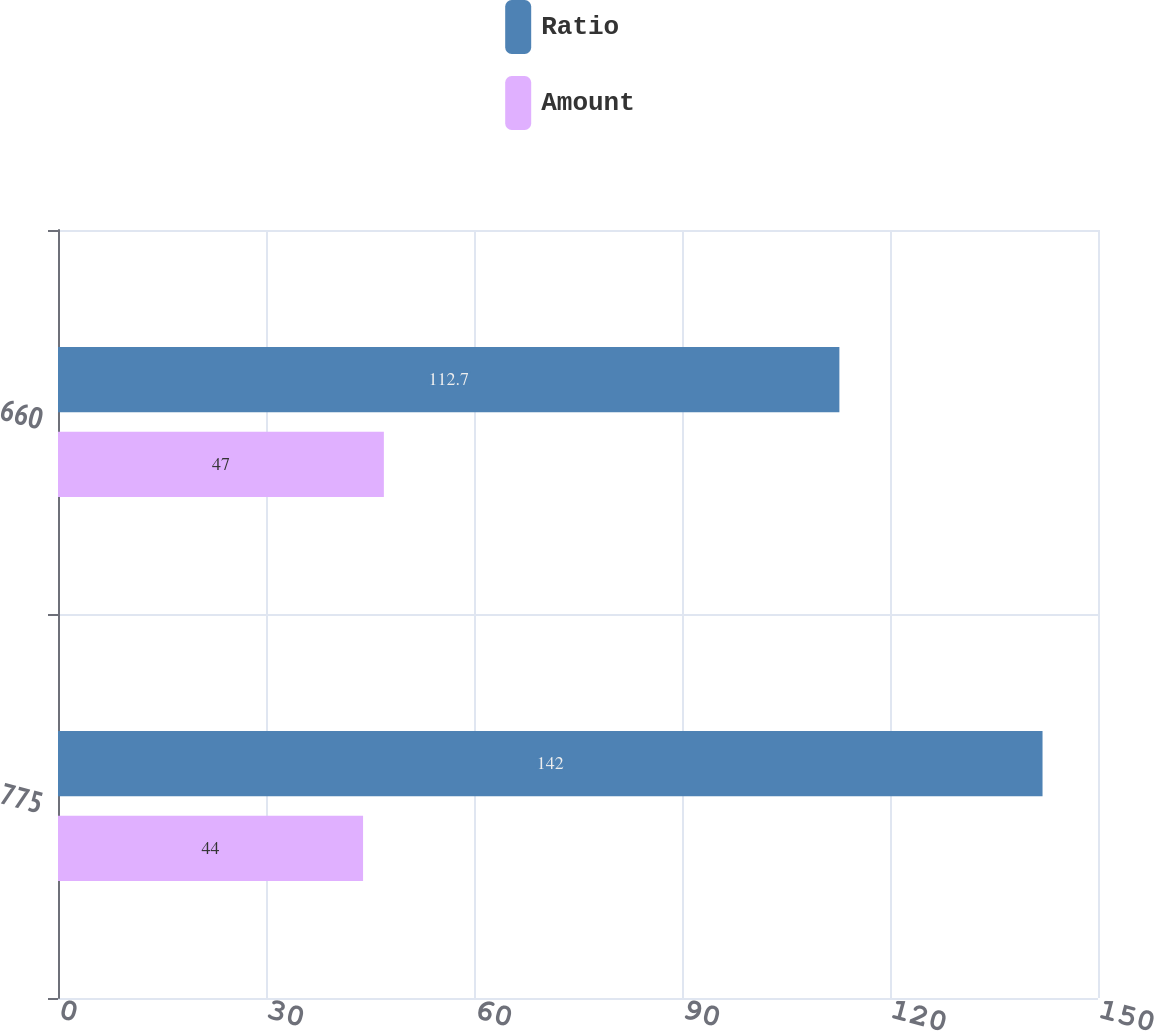Convert chart to OTSL. <chart><loc_0><loc_0><loc_500><loc_500><stacked_bar_chart><ecel><fcel>775<fcel>660<nl><fcel>Ratio<fcel>142<fcel>112.7<nl><fcel>Amount<fcel>44<fcel>47<nl></chart> 